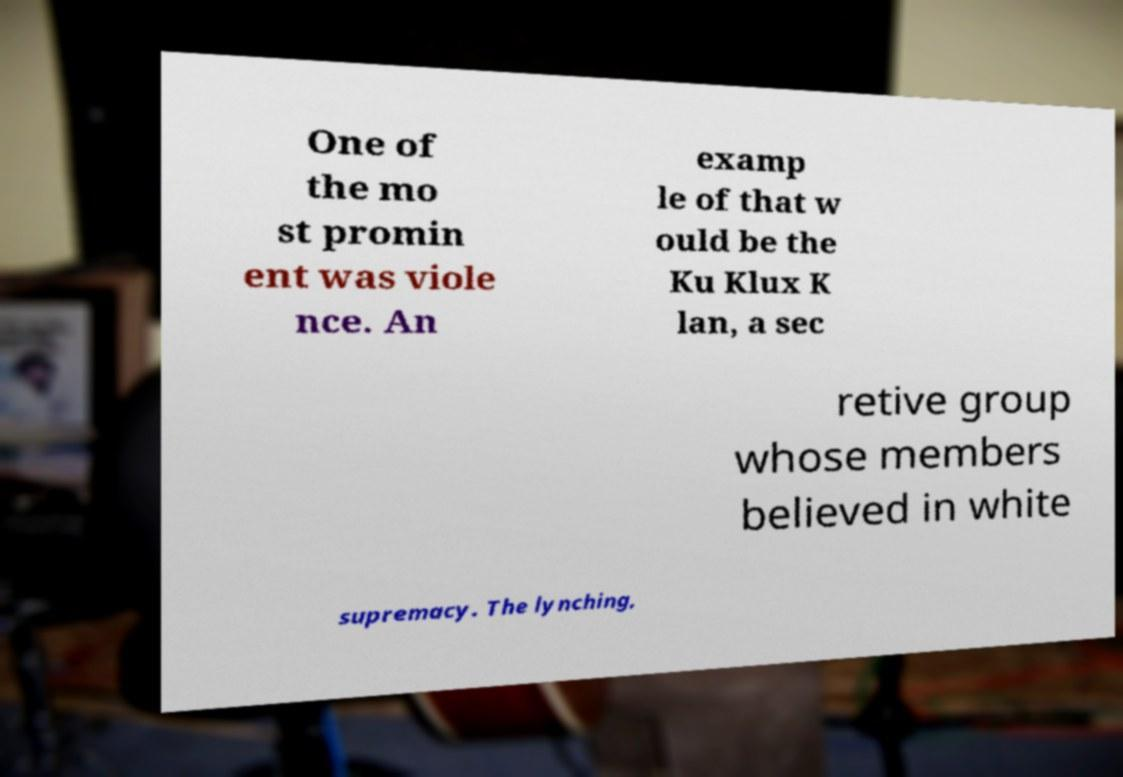I need the written content from this picture converted into text. Can you do that? One of the mo st promin ent was viole nce. An examp le of that w ould be the Ku Klux K lan, a sec retive group whose members believed in white supremacy. The lynching, 